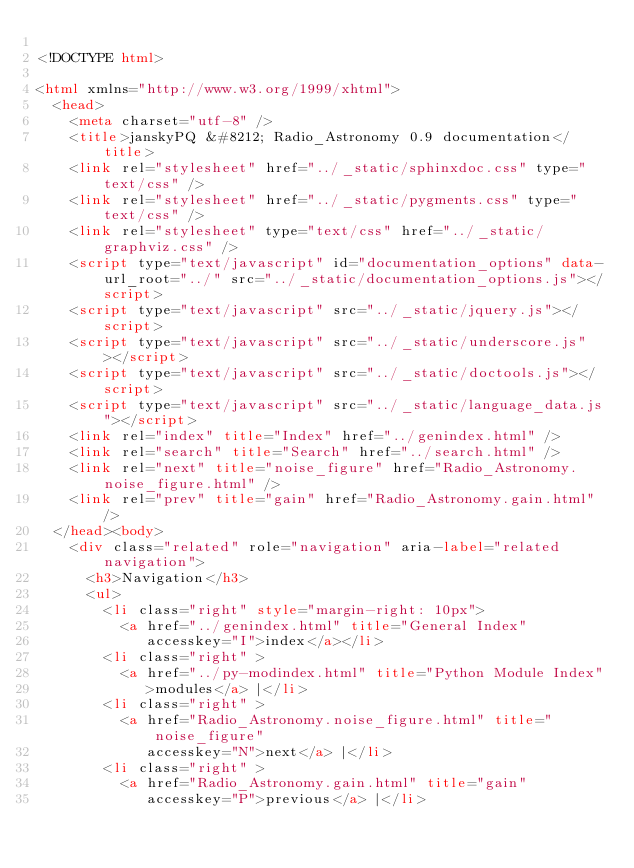Convert code to text. <code><loc_0><loc_0><loc_500><loc_500><_HTML_>
<!DOCTYPE html>

<html xmlns="http://www.w3.org/1999/xhtml">
  <head>
    <meta charset="utf-8" />
    <title>janskyPQ &#8212; Radio_Astronomy 0.9 documentation</title>
    <link rel="stylesheet" href="../_static/sphinxdoc.css" type="text/css" />
    <link rel="stylesheet" href="../_static/pygments.css" type="text/css" />
    <link rel="stylesheet" type="text/css" href="../_static/graphviz.css" />
    <script type="text/javascript" id="documentation_options" data-url_root="../" src="../_static/documentation_options.js"></script>
    <script type="text/javascript" src="../_static/jquery.js"></script>
    <script type="text/javascript" src="../_static/underscore.js"></script>
    <script type="text/javascript" src="../_static/doctools.js"></script>
    <script type="text/javascript" src="../_static/language_data.js"></script>
    <link rel="index" title="Index" href="../genindex.html" />
    <link rel="search" title="Search" href="../search.html" />
    <link rel="next" title="noise_figure" href="Radio_Astronomy.noise_figure.html" />
    <link rel="prev" title="gain" href="Radio_Astronomy.gain.html" /> 
  </head><body>
    <div class="related" role="navigation" aria-label="related navigation">
      <h3>Navigation</h3>
      <ul>
        <li class="right" style="margin-right: 10px">
          <a href="../genindex.html" title="General Index"
             accesskey="I">index</a></li>
        <li class="right" >
          <a href="../py-modindex.html" title="Python Module Index"
             >modules</a> |</li>
        <li class="right" >
          <a href="Radio_Astronomy.noise_figure.html" title="noise_figure"
             accesskey="N">next</a> |</li>
        <li class="right" >
          <a href="Radio_Astronomy.gain.html" title="gain"
             accesskey="P">previous</a> |</li></code> 